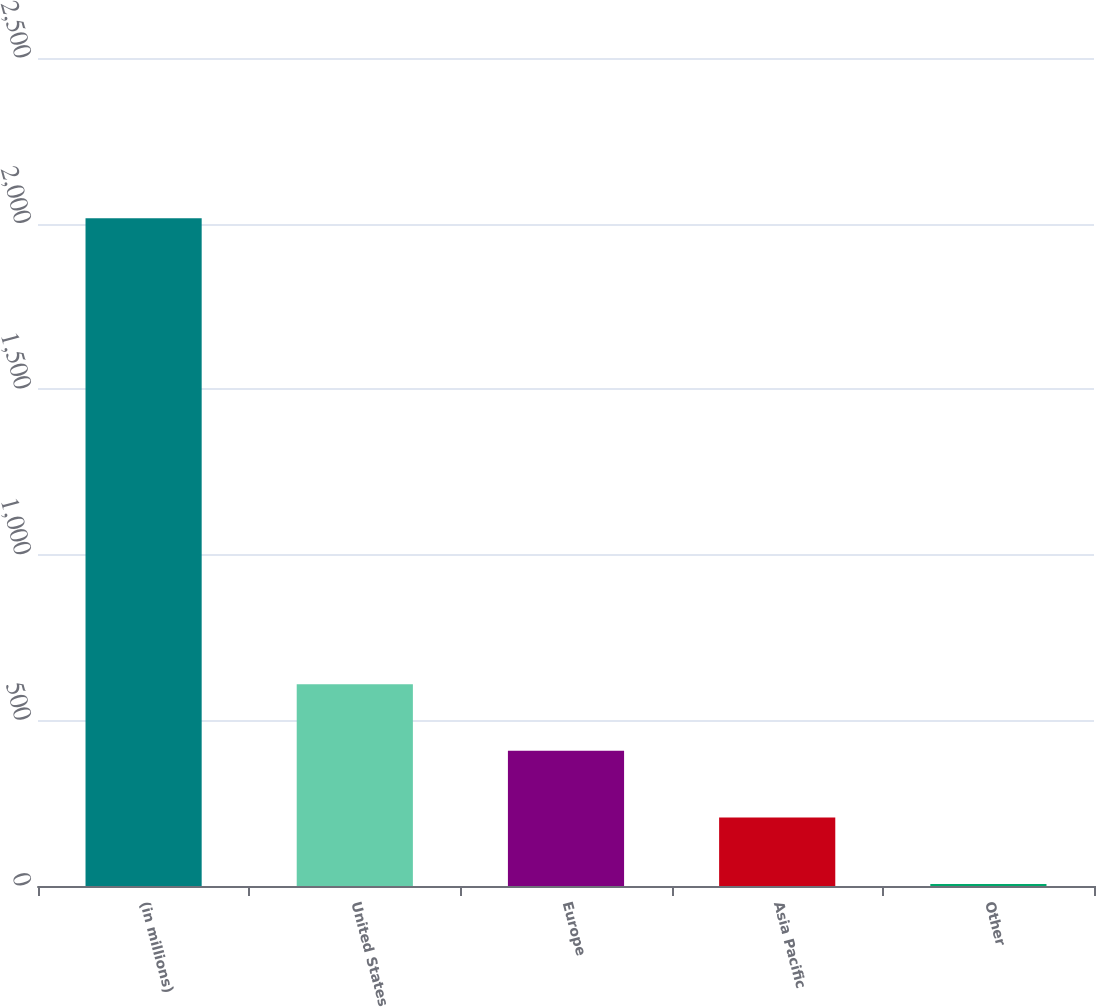<chart> <loc_0><loc_0><loc_500><loc_500><bar_chart><fcel>(in millions)<fcel>United States<fcel>Europe<fcel>Asia Pacific<fcel>Other<nl><fcel>2016<fcel>609<fcel>408<fcel>207<fcel>6<nl></chart> 